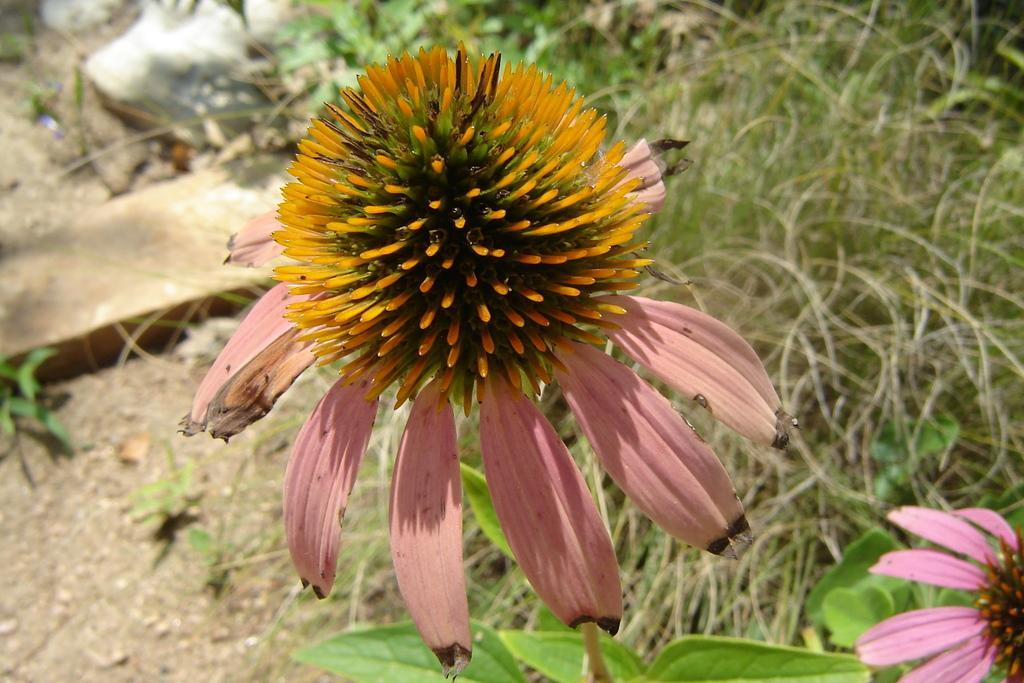In one or two sentences, can you explain what this image depicts? As we can see in the image there is a flower, plant and dry grass. 